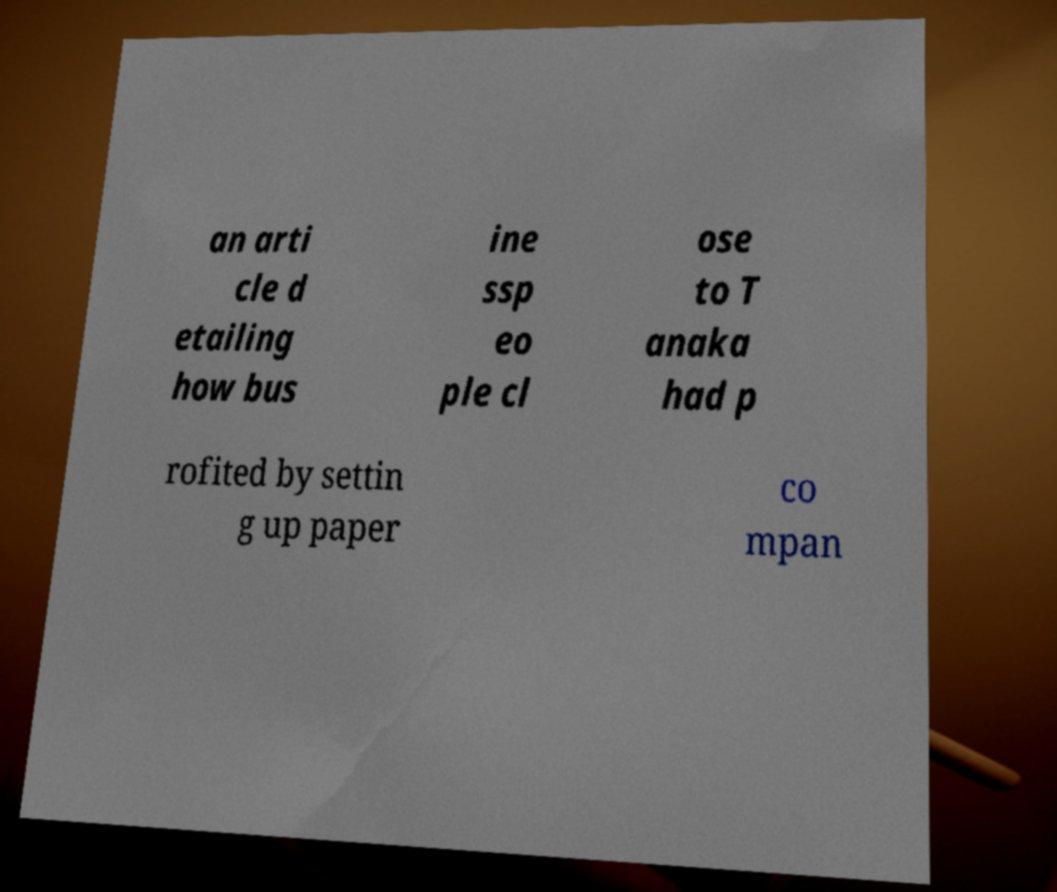Can you accurately transcribe the text from the provided image for me? an arti cle d etailing how bus ine ssp eo ple cl ose to T anaka had p rofited by settin g up paper co mpan 